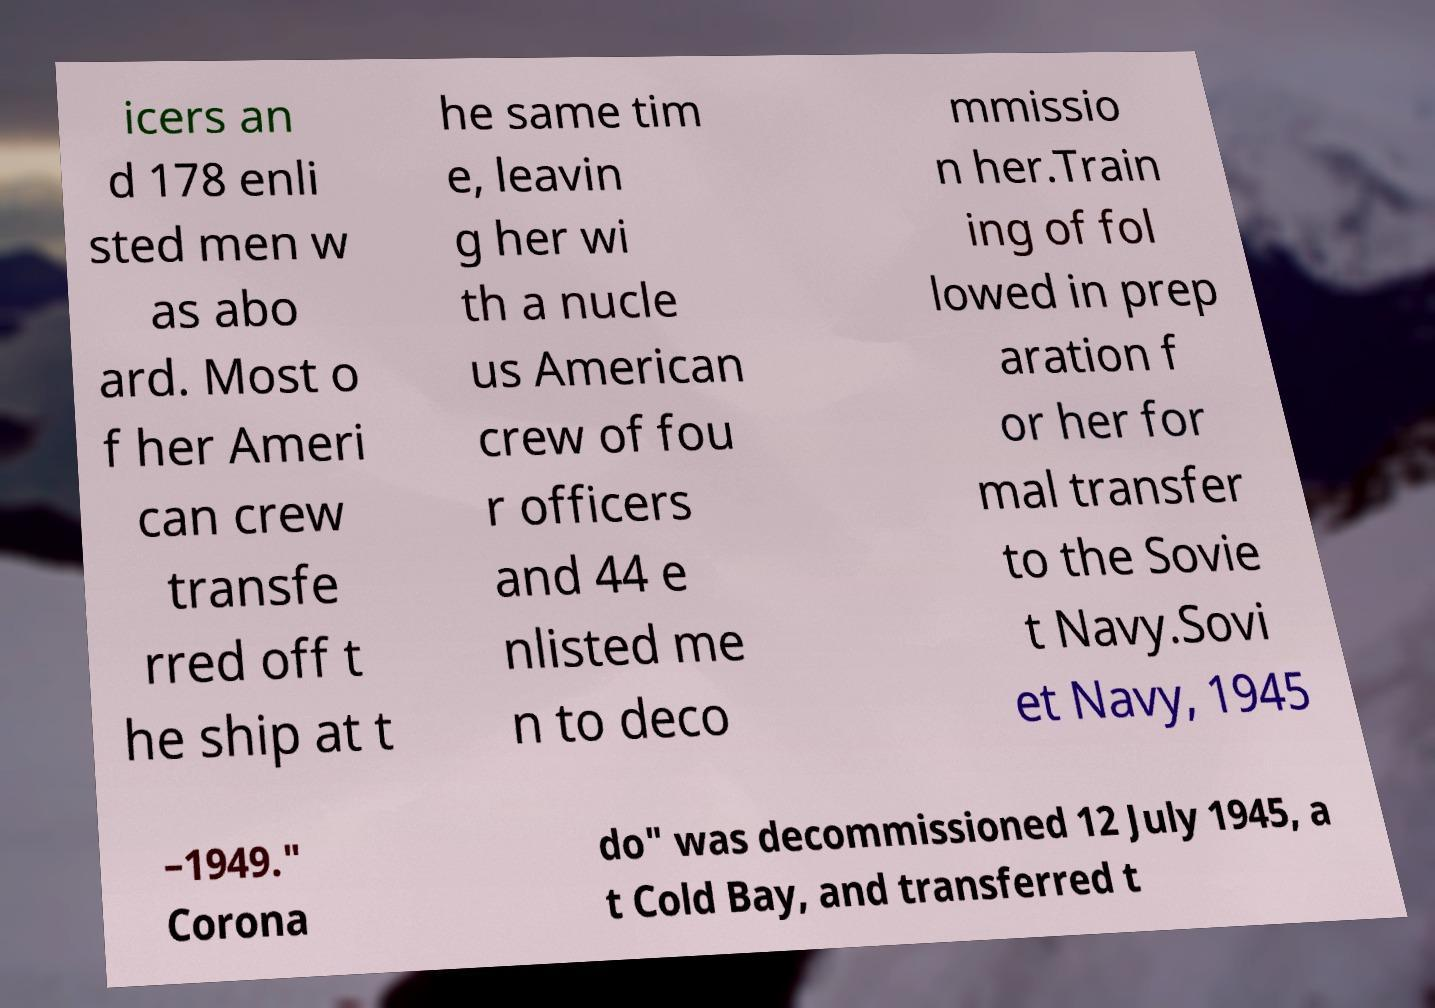Can you accurately transcribe the text from the provided image for me? icers an d 178 enli sted men w as abo ard. Most o f her Ameri can crew transfe rred off t he ship at t he same tim e, leavin g her wi th a nucle us American crew of fou r officers and 44 e nlisted me n to deco mmissio n her.Train ing of fol lowed in prep aration f or her for mal transfer to the Sovie t Navy.Sovi et Navy, 1945 –1949." Corona do" was decommissioned 12 July 1945, a t Cold Bay, and transferred t 